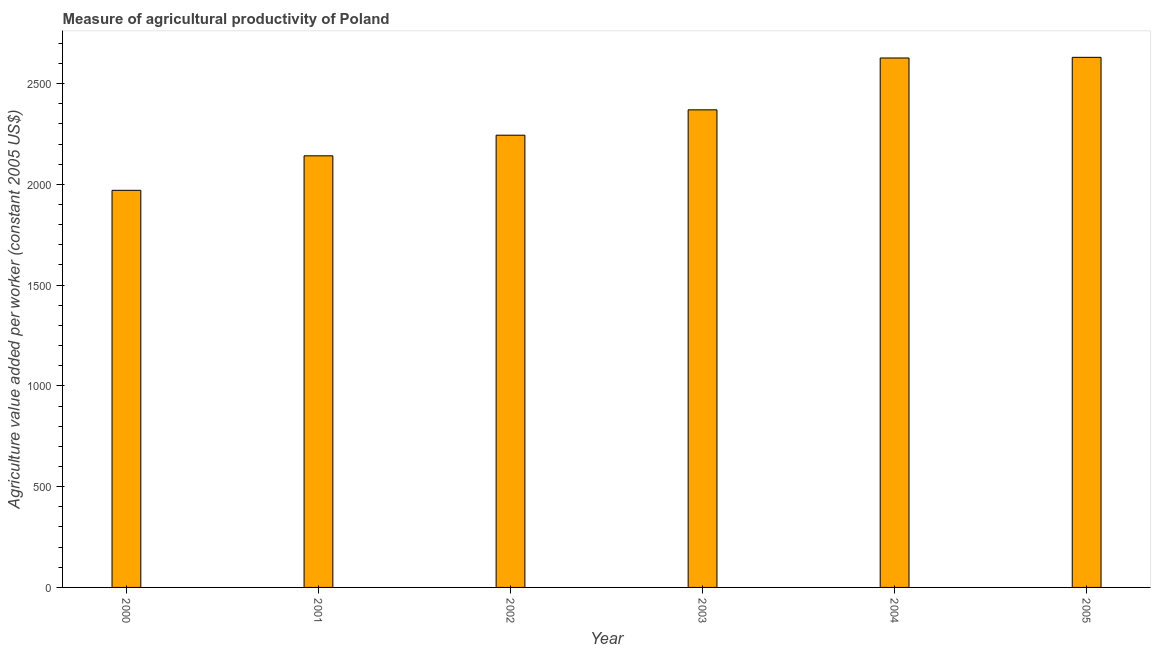Does the graph contain grids?
Keep it short and to the point. No. What is the title of the graph?
Keep it short and to the point. Measure of agricultural productivity of Poland. What is the label or title of the X-axis?
Your answer should be very brief. Year. What is the label or title of the Y-axis?
Keep it short and to the point. Agriculture value added per worker (constant 2005 US$). What is the agriculture value added per worker in 2003?
Provide a short and direct response. 2369.56. Across all years, what is the maximum agriculture value added per worker?
Offer a very short reply. 2630.05. Across all years, what is the minimum agriculture value added per worker?
Make the answer very short. 1970.25. In which year was the agriculture value added per worker maximum?
Offer a terse response. 2005. What is the sum of the agriculture value added per worker?
Provide a succinct answer. 1.40e+04. What is the difference between the agriculture value added per worker in 2000 and 2002?
Offer a terse response. -273.45. What is the average agriculture value added per worker per year?
Provide a short and direct response. 2330.29. What is the median agriculture value added per worker?
Your answer should be very brief. 2306.63. Do a majority of the years between 2002 and 2004 (inclusive) have agriculture value added per worker greater than 600 US$?
Make the answer very short. Yes. What is the ratio of the agriculture value added per worker in 2001 to that in 2004?
Your response must be concise. 0.81. Is the difference between the agriculture value added per worker in 2001 and 2002 greater than the difference between any two years?
Provide a succinct answer. No. What is the difference between the highest and the second highest agriculture value added per worker?
Offer a terse response. 3.25. What is the difference between the highest and the lowest agriculture value added per worker?
Keep it short and to the point. 659.79. How many bars are there?
Ensure brevity in your answer.  6. How many years are there in the graph?
Give a very brief answer. 6. Are the values on the major ticks of Y-axis written in scientific E-notation?
Offer a terse response. No. What is the Agriculture value added per worker (constant 2005 US$) in 2000?
Provide a succinct answer. 1970.25. What is the Agriculture value added per worker (constant 2005 US$) of 2001?
Your response must be concise. 2141.41. What is the Agriculture value added per worker (constant 2005 US$) in 2002?
Keep it short and to the point. 2243.7. What is the Agriculture value added per worker (constant 2005 US$) in 2003?
Your answer should be compact. 2369.56. What is the Agriculture value added per worker (constant 2005 US$) of 2004?
Make the answer very short. 2626.79. What is the Agriculture value added per worker (constant 2005 US$) in 2005?
Make the answer very short. 2630.05. What is the difference between the Agriculture value added per worker (constant 2005 US$) in 2000 and 2001?
Make the answer very short. -171.16. What is the difference between the Agriculture value added per worker (constant 2005 US$) in 2000 and 2002?
Offer a very short reply. -273.45. What is the difference between the Agriculture value added per worker (constant 2005 US$) in 2000 and 2003?
Give a very brief answer. -399.3. What is the difference between the Agriculture value added per worker (constant 2005 US$) in 2000 and 2004?
Give a very brief answer. -656.54. What is the difference between the Agriculture value added per worker (constant 2005 US$) in 2000 and 2005?
Offer a very short reply. -659.79. What is the difference between the Agriculture value added per worker (constant 2005 US$) in 2001 and 2002?
Your answer should be very brief. -102.29. What is the difference between the Agriculture value added per worker (constant 2005 US$) in 2001 and 2003?
Offer a terse response. -228.15. What is the difference between the Agriculture value added per worker (constant 2005 US$) in 2001 and 2004?
Your response must be concise. -485.38. What is the difference between the Agriculture value added per worker (constant 2005 US$) in 2001 and 2005?
Keep it short and to the point. -488.64. What is the difference between the Agriculture value added per worker (constant 2005 US$) in 2002 and 2003?
Your answer should be very brief. -125.86. What is the difference between the Agriculture value added per worker (constant 2005 US$) in 2002 and 2004?
Provide a short and direct response. -383.09. What is the difference between the Agriculture value added per worker (constant 2005 US$) in 2002 and 2005?
Your answer should be very brief. -386.34. What is the difference between the Agriculture value added per worker (constant 2005 US$) in 2003 and 2004?
Ensure brevity in your answer.  -257.23. What is the difference between the Agriculture value added per worker (constant 2005 US$) in 2003 and 2005?
Give a very brief answer. -260.49. What is the difference between the Agriculture value added per worker (constant 2005 US$) in 2004 and 2005?
Offer a very short reply. -3.25. What is the ratio of the Agriculture value added per worker (constant 2005 US$) in 2000 to that in 2001?
Offer a terse response. 0.92. What is the ratio of the Agriculture value added per worker (constant 2005 US$) in 2000 to that in 2002?
Give a very brief answer. 0.88. What is the ratio of the Agriculture value added per worker (constant 2005 US$) in 2000 to that in 2003?
Give a very brief answer. 0.83. What is the ratio of the Agriculture value added per worker (constant 2005 US$) in 2000 to that in 2005?
Offer a terse response. 0.75. What is the ratio of the Agriculture value added per worker (constant 2005 US$) in 2001 to that in 2002?
Provide a succinct answer. 0.95. What is the ratio of the Agriculture value added per worker (constant 2005 US$) in 2001 to that in 2003?
Ensure brevity in your answer.  0.9. What is the ratio of the Agriculture value added per worker (constant 2005 US$) in 2001 to that in 2004?
Your answer should be compact. 0.81. What is the ratio of the Agriculture value added per worker (constant 2005 US$) in 2001 to that in 2005?
Make the answer very short. 0.81. What is the ratio of the Agriculture value added per worker (constant 2005 US$) in 2002 to that in 2003?
Provide a short and direct response. 0.95. What is the ratio of the Agriculture value added per worker (constant 2005 US$) in 2002 to that in 2004?
Provide a succinct answer. 0.85. What is the ratio of the Agriculture value added per worker (constant 2005 US$) in 2002 to that in 2005?
Give a very brief answer. 0.85. What is the ratio of the Agriculture value added per worker (constant 2005 US$) in 2003 to that in 2004?
Give a very brief answer. 0.9. What is the ratio of the Agriculture value added per worker (constant 2005 US$) in 2003 to that in 2005?
Provide a short and direct response. 0.9. 